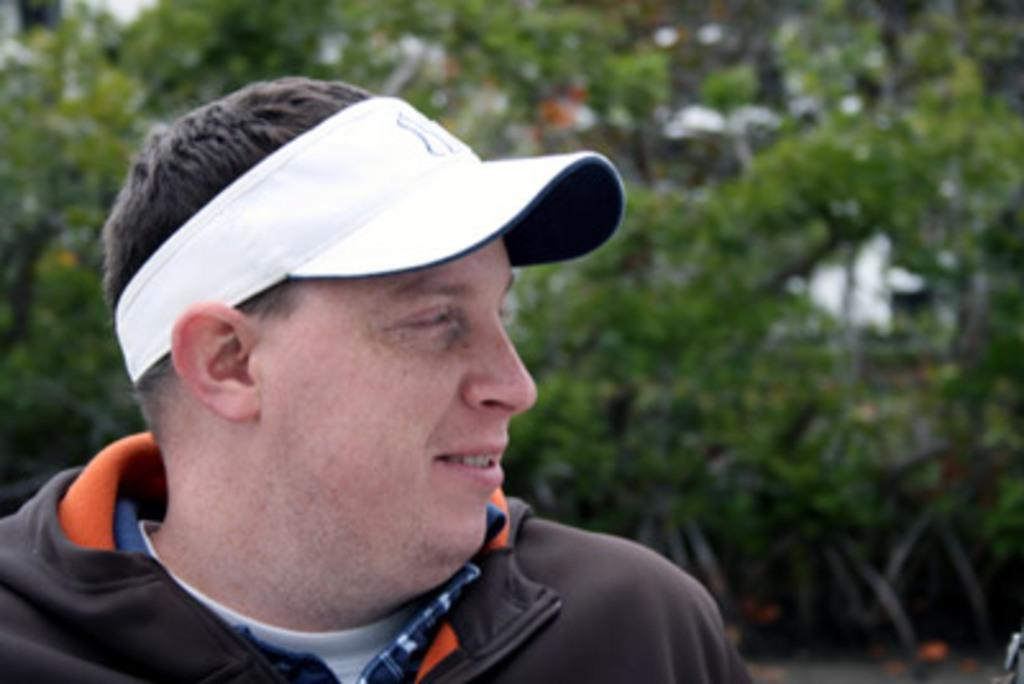What is the main subject of the picture? The main subject of the picture is a man. What is the man doing in the picture? The man is standing in the picture. What direction is the man looking in? The man is looking aside in the picture. What is the man wearing on his upper body? The man is wearing a black T-shirt. What is the man wearing on his head? The man is wearing a white cap. What can be seen in the background of the picture? There are trees visible behind the man. What type of bells can be heard ringing in the image? There are no bells present in the image, and therefore no sound can be heard. 